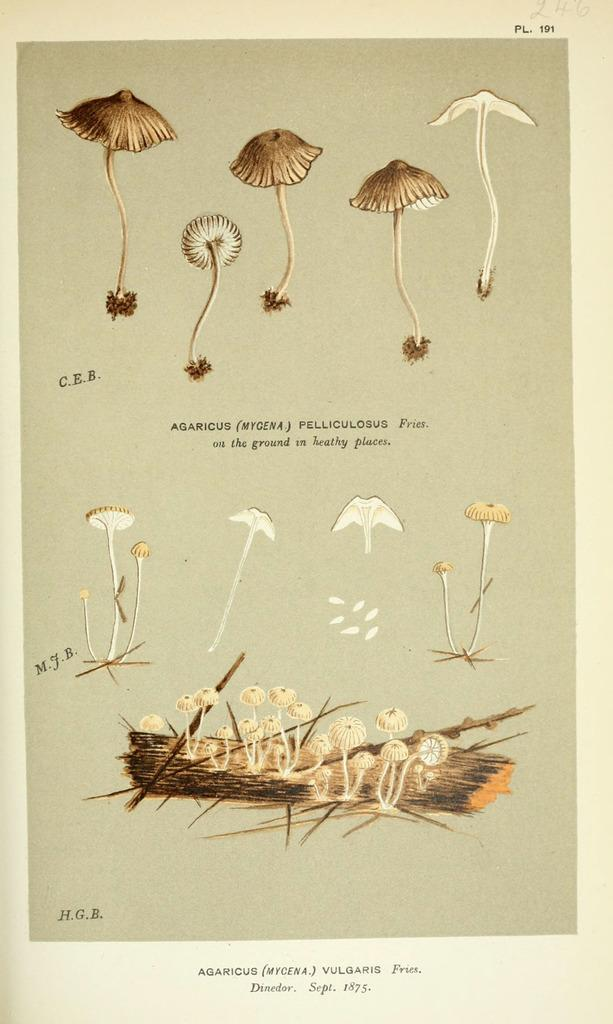What is the medium of the image? The image appears to be on paper. What type of objects are depicted in the image? There are pictures of mushrooms in the image. What type of knee is visible in the image? There is no knee present in the image; it features pictures of mushrooms. What does the queen say about the mushrooms in the image? There is no queen present in the image, and therefore no dialogue can be attributed to her. 